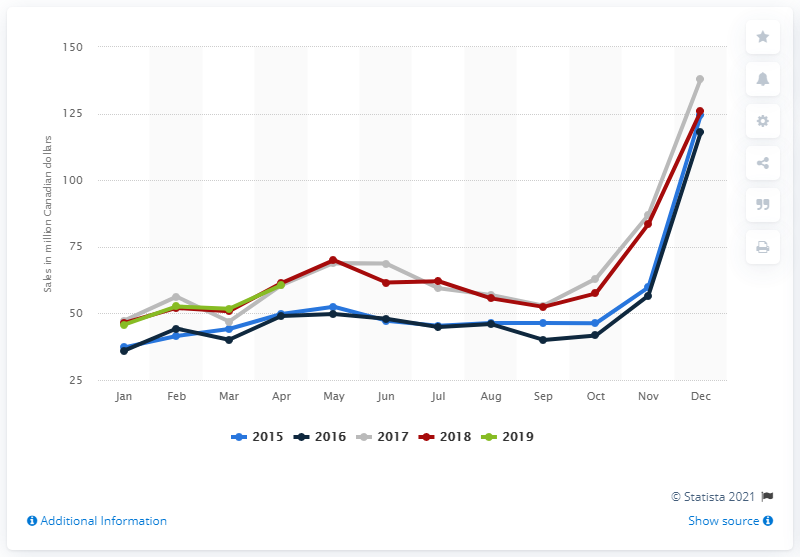Specify some key components in this picture. In December of 2018, the sale of jewelry and watches in Canada totaled 125.87 Canadian dollars. In April 2019, jewelry and watches sold for a total of 60.64 Canadian dollars. 